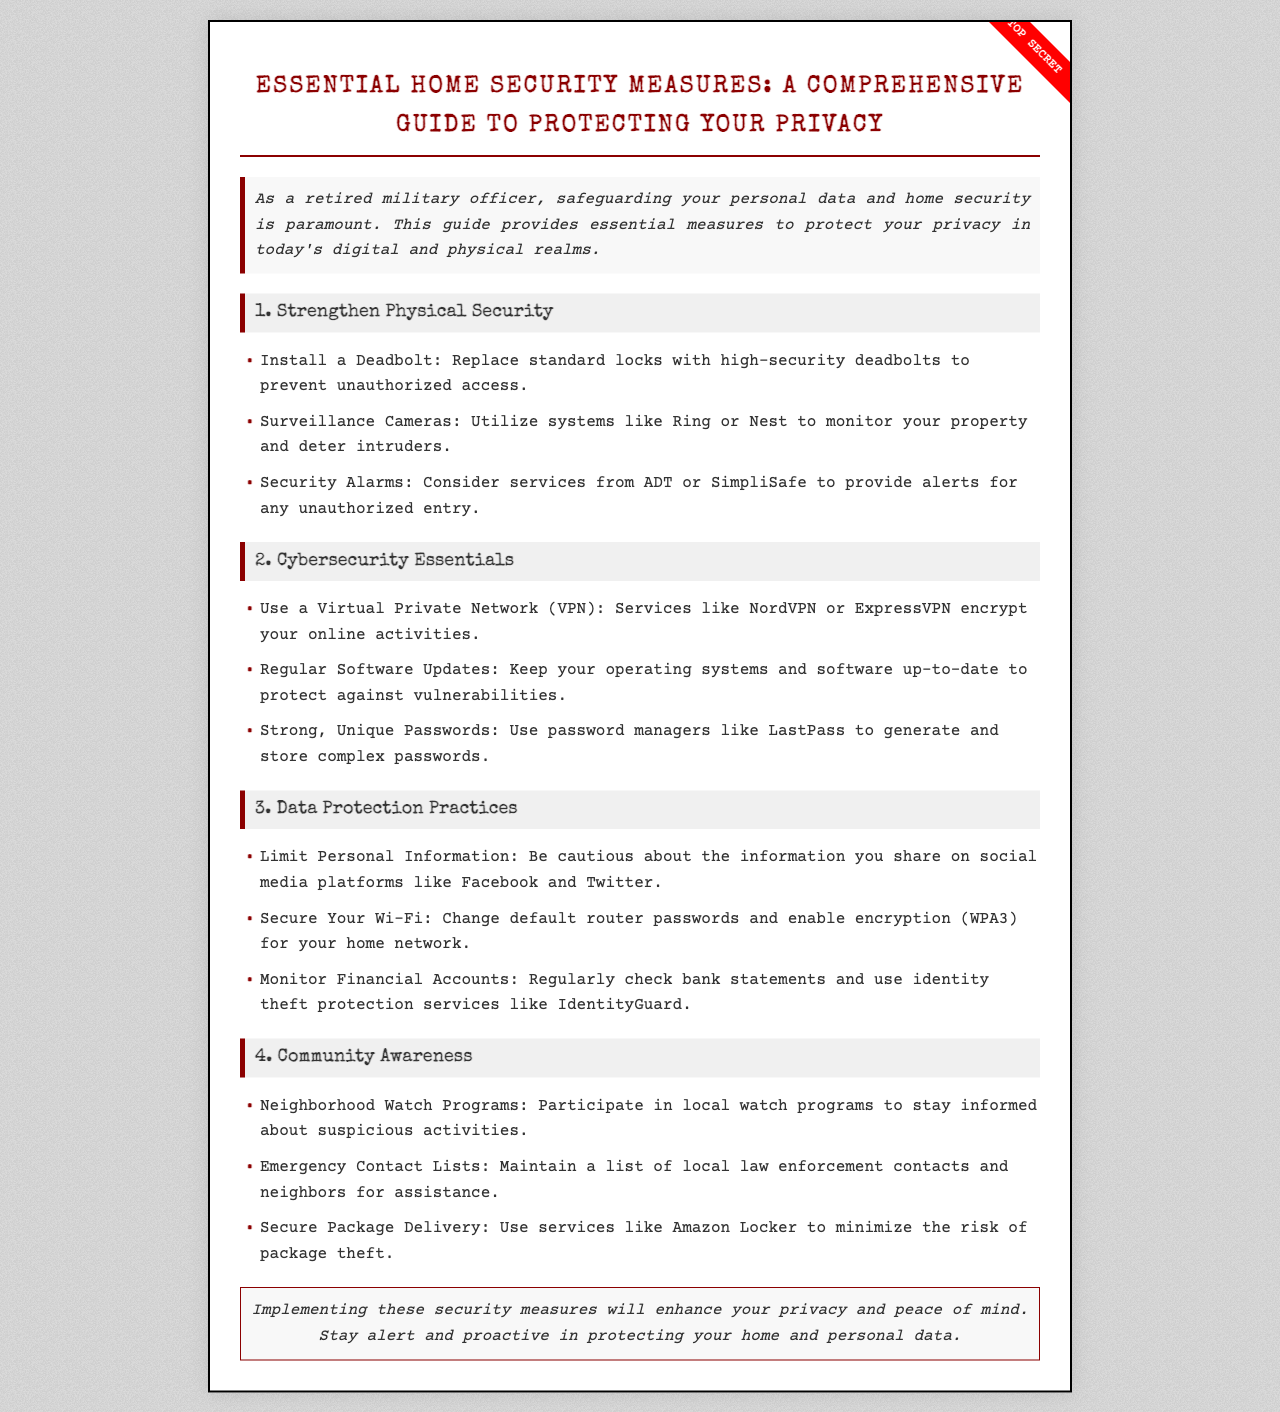what is the title of the brochure? The title summarizes the main focus of the document, which is to provide information on home security measures.
Answer: Essential Home Security Measures: A Comprehensive Guide to Protecting Your Privacy how many sections are there in the brochure? The brochure is divided into four specific sections that cover different areas of security.
Answer: 4 what is the first security measure suggested in "Strengthen Physical Security"? This measurement is the first point mentioned in the section about physical security measures.
Answer: Install a Deadbolt which VPN service is mentioned in the cybersecurity essentials section? The mentioned VPN service provides encryption for online activities.
Answer: NordVPN what is recommended for monitoring financial accounts? This advice pertains to safeguarding financial information from unauthorized access.
Answer: Use identity theft protection services like IdentityGuard why is community awareness important according to the brochure? This question relates to the reasoning behind being involved in local safety initiatives.
Answer: To stay informed about suspicious activities what type of programs does the brochure recommend for community security? These programs involve local residents working together for security purposes.
Answer: Neighborhood Watch Programs where can you use to secure package delivery? This question seeks to identify a service aimed at preventing theft during deliveries.
Answer: Amazon Locker what does the brochure emphasize at the end? This question looks for the main takeaway or message provided in the conclusion of the document.
Answer: Enhance your privacy and peace of mind 